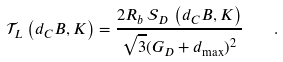<formula> <loc_0><loc_0><loc_500><loc_500>\mathcal { T } _ { L } \left ( d _ { C } B , K \right ) = \frac { 2 R _ { b } \, \mathcal { S } _ { D } \, \left ( d _ { C } B , K \right ) } { \sqrt { 3 } ( G _ { D } + d _ { \max } ) ^ { 2 } } \quad .</formula> 